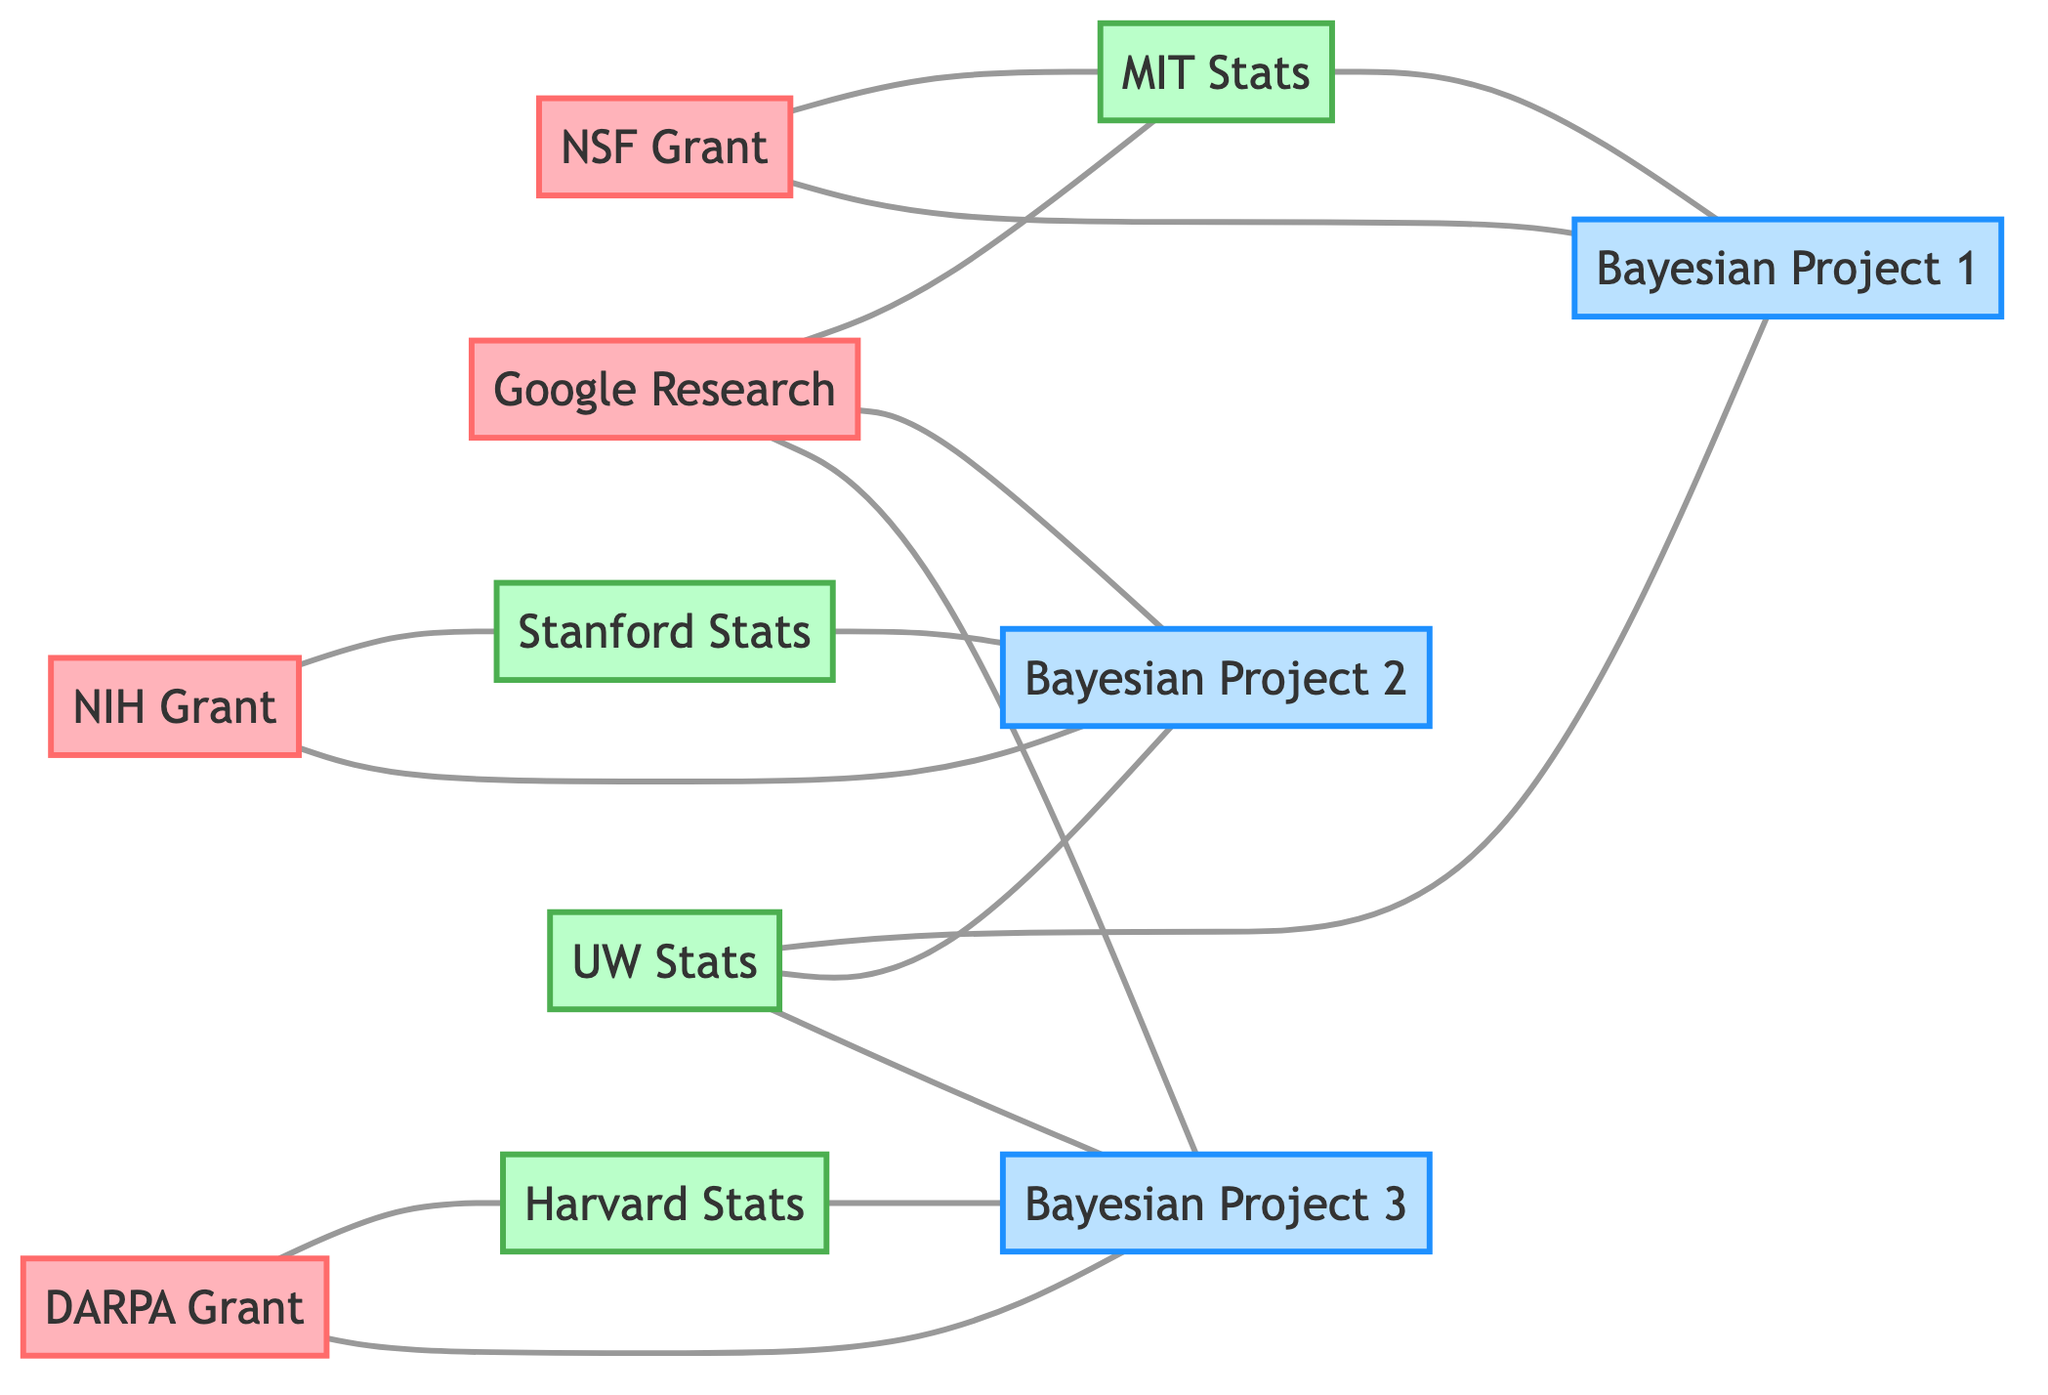What is the number of funding sources represented in the diagram? There are four funding sources in the diagram: NSF Grant, NIH Grant, DARPA Grant, and Google Research.
Answer: 4 Which research project is connected to the MIT Statistics Department? The MIT Statistics Department is directly connected to Bayesian Inference Research Project 1. The edge indicates that the department is involved in that specific project.
Answer: Bayesian Inference Research Project 1 How many projects are connected to the University of Washington Statistics Department? The University of Washington Statistics Department is connected to three projects: Bayesian Inference Research Project 1, Bayesian Inference Research Project 2, and Bayesian Inference Research Project 3. Each project has a direct edge connecting it to the department.
Answer: 3 Which funding source is linked to the Stanford Statistics Department? The NIH Grant is linked to the Stanford Statistics Department, as indicated by the edge connecting them in the diagram.
Answer: NIH Grant How many total edges (connections) are present in the diagram? The diagram contains a total of 13 edges connecting the various funding sources, departments, and research projects. Each connection represents a relationship between the nodes.
Answer: 13 Which department has connections to the most projects? The University of Washington Statistics Department has connections to all three projects: Bayesian Inference Research Project 1, Bayesian Inference Research Project 2, and Bayesian Inference Research Project 3, making it the department with the most connections.
Answer: University of Washington Statistics Department What is the link between DARPA Grant and research projects? The DARPA Grant is linked to Bayesian Inference Research Project 3, as shown by the edge in the graph indicating a direct connection between the two.
Answer: Bayesian Inference Research Project 3 What is the relationship between the Google Research and the Bayesian Inference Research Project 2? Google Research is directly connected to Bayesian Inference Research Project 2 through an edge, indicating a relationship or funding connection between them.
Answer: Connected 